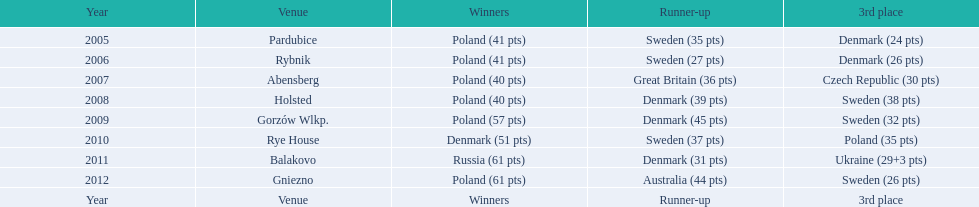After enjoying five consecutive victories at the team speedway junior world championship poland was finally unseated in what year? 2010. In that year, what teams placed first through third? Denmark (51 pts), Sweden (37 pts), Poland (35 pts). Which of those positions did poland specifically place in? 3rd place. 